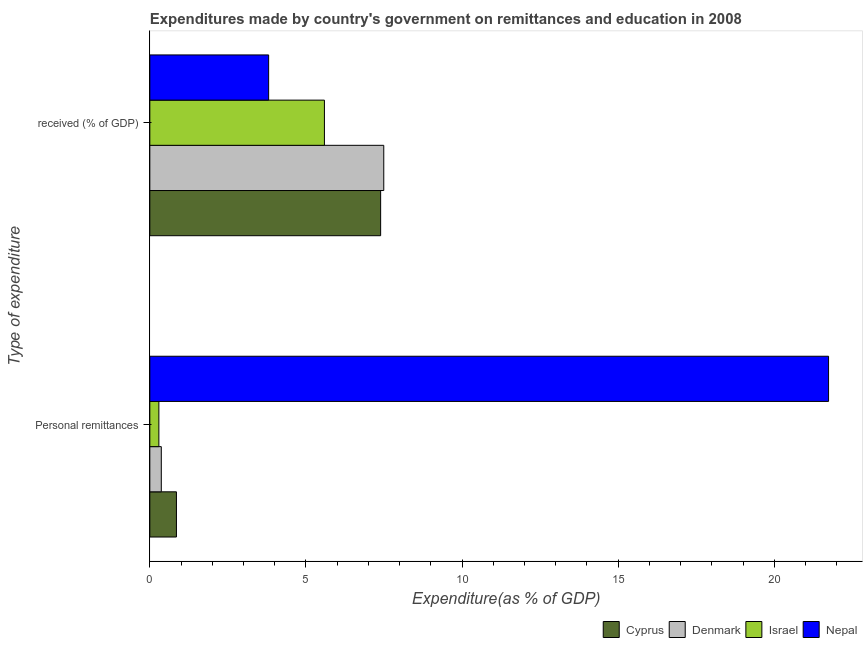How many different coloured bars are there?
Offer a terse response. 4. How many groups of bars are there?
Provide a succinct answer. 2. Are the number of bars on each tick of the Y-axis equal?
Give a very brief answer. Yes. How many bars are there on the 1st tick from the bottom?
Offer a very short reply. 4. What is the label of the 2nd group of bars from the top?
Give a very brief answer. Personal remittances. What is the expenditure in personal remittances in Nepal?
Your response must be concise. 21.74. Across all countries, what is the maximum expenditure in personal remittances?
Offer a very short reply. 21.74. Across all countries, what is the minimum expenditure in personal remittances?
Provide a short and direct response. 0.29. In which country was the expenditure in personal remittances minimum?
Your answer should be compact. Israel. What is the total expenditure in education in the graph?
Your answer should be compact. 24.28. What is the difference between the expenditure in education in Nepal and that in Cyprus?
Your response must be concise. -3.59. What is the difference between the expenditure in education in Israel and the expenditure in personal remittances in Denmark?
Your response must be concise. 5.22. What is the average expenditure in personal remittances per country?
Offer a very short reply. 5.81. What is the difference between the expenditure in personal remittances and expenditure in education in Denmark?
Keep it short and to the point. -7.12. What is the ratio of the expenditure in personal remittances in Nepal to that in Denmark?
Provide a succinct answer. 59.17. Is the expenditure in education in Denmark less than that in Cyprus?
Give a very brief answer. No. In how many countries, is the expenditure in education greater than the average expenditure in education taken over all countries?
Offer a terse response. 2. What does the 3rd bar from the top in  received (% of GDP) represents?
Your answer should be compact. Denmark. What does the 4th bar from the bottom in  received (% of GDP) represents?
Give a very brief answer. Nepal. How many bars are there?
Offer a very short reply. 8. How many countries are there in the graph?
Provide a short and direct response. 4. What is the difference between two consecutive major ticks on the X-axis?
Offer a terse response. 5. Does the graph contain grids?
Keep it short and to the point. No. How are the legend labels stacked?
Make the answer very short. Horizontal. What is the title of the graph?
Keep it short and to the point. Expenditures made by country's government on remittances and education in 2008. Does "Mauritania" appear as one of the legend labels in the graph?
Your answer should be very brief. No. What is the label or title of the X-axis?
Make the answer very short. Expenditure(as % of GDP). What is the label or title of the Y-axis?
Offer a terse response. Type of expenditure. What is the Expenditure(as % of GDP) in Cyprus in Personal remittances?
Give a very brief answer. 0.85. What is the Expenditure(as % of GDP) of Denmark in Personal remittances?
Your answer should be very brief. 0.37. What is the Expenditure(as % of GDP) of Israel in Personal remittances?
Give a very brief answer. 0.29. What is the Expenditure(as % of GDP) in Nepal in Personal remittances?
Your answer should be very brief. 21.74. What is the Expenditure(as % of GDP) of Cyprus in  received (% of GDP)?
Offer a very short reply. 7.39. What is the Expenditure(as % of GDP) in Denmark in  received (% of GDP)?
Provide a short and direct response. 7.49. What is the Expenditure(as % of GDP) in Israel in  received (% of GDP)?
Ensure brevity in your answer.  5.59. What is the Expenditure(as % of GDP) of Nepal in  received (% of GDP)?
Your answer should be very brief. 3.81. Across all Type of expenditure, what is the maximum Expenditure(as % of GDP) in Cyprus?
Keep it short and to the point. 7.39. Across all Type of expenditure, what is the maximum Expenditure(as % of GDP) of Denmark?
Keep it short and to the point. 7.49. Across all Type of expenditure, what is the maximum Expenditure(as % of GDP) of Israel?
Offer a terse response. 5.59. Across all Type of expenditure, what is the maximum Expenditure(as % of GDP) of Nepal?
Give a very brief answer. 21.74. Across all Type of expenditure, what is the minimum Expenditure(as % of GDP) of Cyprus?
Offer a terse response. 0.85. Across all Type of expenditure, what is the minimum Expenditure(as % of GDP) in Denmark?
Keep it short and to the point. 0.37. Across all Type of expenditure, what is the minimum Expenditure(as % of GDP) of Israel?
Give a very brief answer. 0.29. Across all Type of expenditure, what is the minimum Expenditure(as % of GDP) of Nepal?
Offer a very short reply. 3.81. What is the total Expenditure(as % of GDP) of Cyprus in the graph?
Your response must be concise. 8.24. What is the total Expenditure(as % of GDP) in Denmark in the graph?
Your response must be concise. 7.86. What is the total Expenditure(as % of GDP) in Israel in the graph?
Make the answer very short. 5.88. What is the total Expenditure(as % of GDP) in Nepal in the graph?
Offer a very short reply. 25.54. What is the difference between the Expenditure(as % of GDP) of Cyprus in Personal remittances and that in  received (% of GDP)?
Make the answer very short. -6.54. What is the difference between the Expenditure(as % of GDP) of Denmark in Personal remittances and that in  received (% of GDP)?
Offer a terse response. -7.12. What is the difference between the Expenditure(as % of GDP) in Israel in Personal remittances and that in  received (% of GDP)?
Keep it short and to the point. -5.3. What is the difference between the Expenditure(as % of GDP) in Nepal in Personal remittances and that in  received (% of GDP)?
Offer a terse response. 17.93. What is the difference between the Expenditure(as % of GDP) of Cyprus in Personal remittances and the Expenditure(as % of GDP) of Denmark in  received (% of GDP)?
Provide a short and direct response. -6.64. What is the difference between the Expenditure(as % of GDP) of Cyprus in Personal remittances and the Expenditure(as % of GDP) of Israel in  received (% of GDP)?
Provide a succinct answer. -4.74. What is the difference between the Expenditure(as % of GDP) of Cyprus in Personal remittances and the Expenditure(as % of GDP) of Nepal in  received (% of GDP)?
Your answer should be compact. -2.95. What is the difference between the Expenditure(as % of GDP) of Denmark in Personal remittances and the Expenditure(as % of GDP) of Israel in  received (% of GDP)?
Make the answer very short. -5.22. What is the difference between the Expenditure(as % of GDP) of Denmark in Personal remittances and the Expenditure(as % of GDP) of Nepal in  received (% of GDP)?
Give a very brief answer. -3.44. What is the difference between the Expenditure(as % of GDP) of Israel in Personal remittances and the Expenditure(as % of GDP) of Nepal in  received (% of GDP)?
Give a very brief answer. -3.52. What is the average Expenditure(as % of GDP) in Cyprus per Type of expenditure?
Your answer should be very brief. 4.12. What is the average Expenditure(as % of GDP) in Denmark per Type of expenditure?
Your answer should be compact. 3.93. What is the average Expenditure(as % of GDP) in Israel per Type of expenditure?
Give a very brief answer. 2.94. What is the average Expenditure(as % of GDP) in Nepal per Type of expenditure?
Keep it short and to the point. 12.77. What is the difference between the Expenditure(as % of GDP) in Cyprus and Expenditure(as % of GDP) in Denmark in Personal remittances?
Give a very brief answer. 0.48. What is the difference between the Expenditure(as % of GDP) of Cyprus and Expenditure(as % of GDP) of Israel in Personal remittances?
Provide a succinct answer. 0.56. What is the difference between the Expenditure(as % of GDP) in Cyprus and Expenditure(as % of GDP) in Nepal in Personal remittances?
Provide a succinct answer. -20.89. What is the difference between the Expenditure(as % of GDP) of Denmark and Expenditure(as % of GDP) of Israel in Personal remittances?
Ensure brevity in your answer.  0.08. What is the difference between the Expenditure(as % of GDP) of Denmark and Expenditure(as % of GDP) of Nepal in Personal remittances?
Provide a succinct answer. -21.37. What is the difference between the Expenditure(as % of GDP) in Israel and Expenditure(as % of GDP) in Nepal in Personal remittances?
Offer a terse response. -21.45. What is the difference between the Expenditure(as % of GDP) in Cyprus and Expenditure(as % of GDP) in Denmark in  received (% of GDP)?
Make the answer very short. -0.1. What is the difference between the Expenditure(as % of GDP) of Cyprus and Expenditure(as % of GDP) of Israel in  received (% of GDP)?
Offer a very short reply. 1.8. What is the difference between the Expenditure(as % of GDP) in Cyprus and Expenditure(as % of GDP) in Nepal in  received (% of GDP)?
Provide a short and direct response. 3.59. What is the difference between the Expenditure(as % of GDP) of Denmark and Expenditure(as % of GDP) of Israel in  received (% of GDP)?
Keep it short and to the point. 1.9. What is the difference between the Expenditure(as % of GDP) in Denmark and Expenditure(as % of GDP) in Nepal in  received (% of GDP)?
Provide a succinct answer. 3.69. What is the difference between the Expenditure(as % of GDP) in Israel and Expenditure(as % of GDP) in Nepal in  received (% of GDP)?
Your response must be concise. 1.79. What is the ratio of the Expenditure(as % of GDP) of Cyprus in Personal remittances to that in  received (% of GDP)?
Ensure brevity in your answer.  0.12. What is the ratio of the Expenditure(as % of GDP) of Denmark in Personal remittances to that in  received (% of GDP)?
Provide a succinct answer. 0.05. What is the ratio of the Expenditure(as % of GDP) in Israel in Personal remittances to that in  received (% of GDP)?
Your answer should be compact. 0.05. What is the ratio of the Expenditure(as % of GDP) of Nepal in Personal remittances to that in  received (% of GDP)?
Offer a terse response. 5.71. What is the difference between the highest and the second highest Expenditure(as % of GDP) in Cyprus?
Ensure brevity in your answer.  6.54. What is the difference between the highest and the second highest Expenditure(as % of GDP) in Denmark?
Offer a terse response. 7.12. What is the difference between the highest and the second highest Expenditure(as % of GDP) of Israel?
Your answer should be very brief. 5.3. What is the difference between the highest and the second highest Expenditure(as % of GDP) in Nepal?
Your response must be concise. 17.93. What is the difference between the highest and the lowest Expenditure(as % of GDP) of Cyprus?
Your response must be concise. 6.54. What is the difference between the highest and the lowest Expenditure(as % of GDP) in Denmark?
Ensure brevity in your answer.  7.12. What is the difference between the highest and the lowest Expenditure(as % of GDP) in Israel?
Ensure brevity in your answer.  5.3. What is the difference between the highest and the lowest Expenditure(as % of GDP) in Nepal?
Provide a succinct answer. 17.93. 